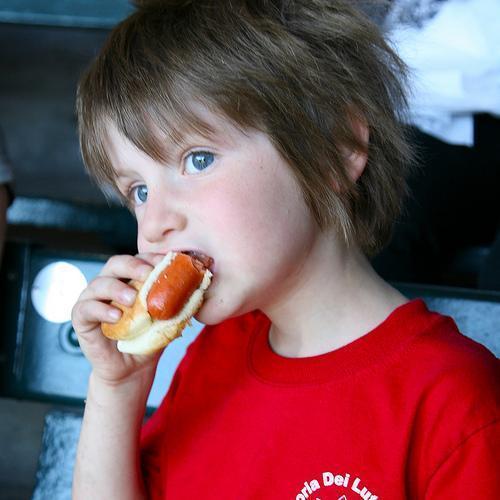How many boys are there?
Give a very brief answer. 1. 